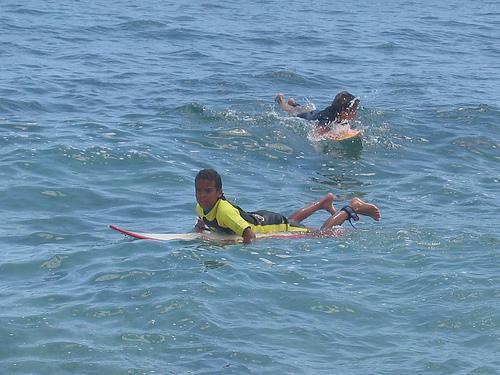How many people are there?
Give a very brief answer. 2. 